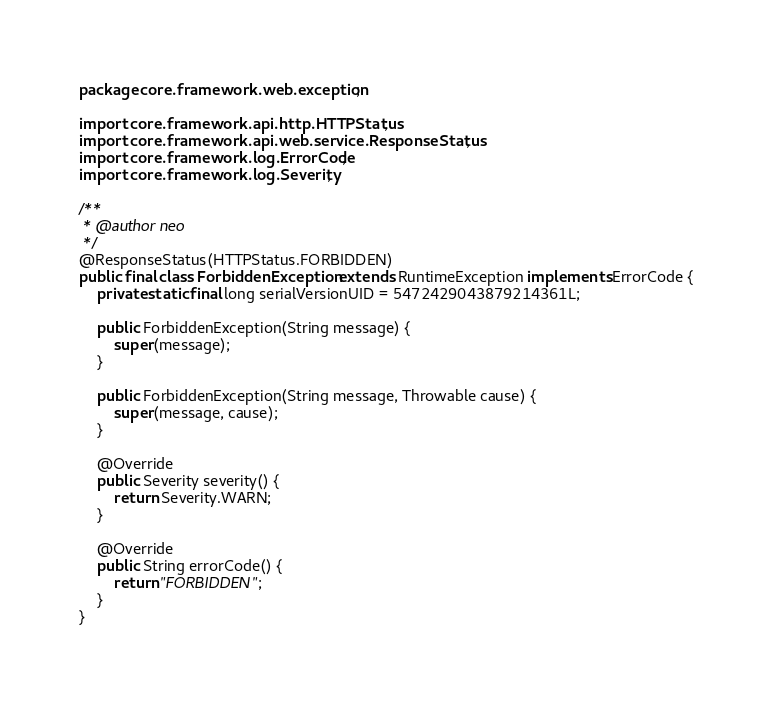Convert code to text. <code><loc_0><loc_0><loc_500><loc_500><_Java_>package core.framework.web.exception;

import core.framework.api.http.HTTPStatus;
import core.framework.api.web.service.ResponseStatus;
import core.framework.log.ErrorCode;
import core.framework.log.Severity;

/**
 * @author neo
 */
@ResponseStatus(HTTPStatus.FORBIDDEN)
public final class ForbiddenException extends RuntimeException implements ErrorCode {
    private static final long serialVersionUID = 5472429043879214361L;

    public ForbiddenException(String message) {
        super(message);
    }

    public ForbiddenException(String message, Throwable cause) {
        super(message, cause);
    }

    @Override
    public Severity severity() {
        return Severity.WARN;
    }

    @Override
    public String errorCode() {
        return "FORBIDDEN";
    }
}
</code> 